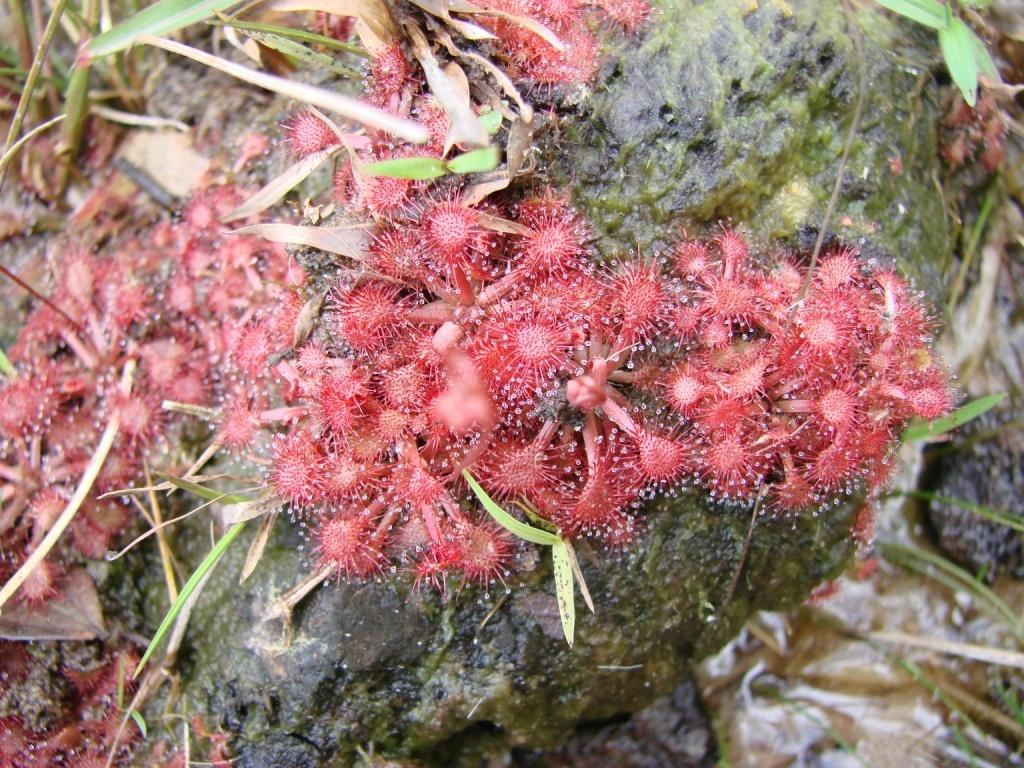What type of living organisms can be seen in the image? The image contains plants and other species. What type of vegetation is visible in the image? There is grass in the image. What type of popcorn is being processed by the women in the image? There are no women or popcorn present in the image. 